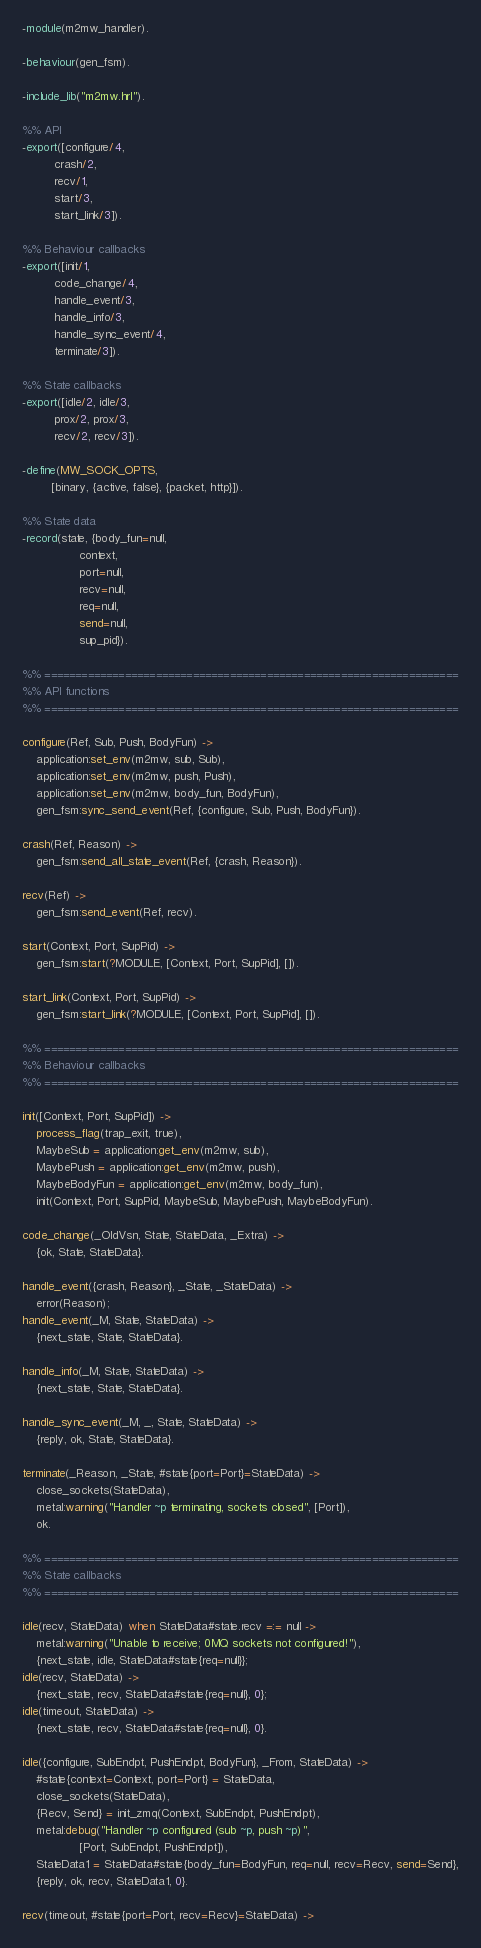Convert code to text. <code><loc_0><loc_0><loc_500><loc_500><_Erlang_>-module(m2mw_handler).

-behaviour(gen_fsm).

-include_lib("m2mw.hrl").

%% API
-export([configure/4,
         crash/2,
         recv/1,
         start/3,
         start_link/3]).

%% Behaviour callbacks
-export([init/1,
         code_change/4,
         handle_event/3,
         handle_info/3,
         handle_sync_event/4,
         terminate/3]).

%% State callbacks
-export([idle/2, idle/3,
         prox/2, prox/3,
         recv/2, recv/3]).

-define(MW_SOCK_OPTS,
        [binary, {active, false}, {packet, http}]).

%% State data
-record(state, {body_fun=null,
                context,
                port=null,
                recv=null,
                req=null,
                send=null,
                sup_pid}).

%% ===================================================================
%% API functions
%% ===================================================================

configure(Ref, Sub, Push, BodyFun) ->
    application:set_env(m2mw, sub, Sub),
    application:set_env(m2mw, push, Push),
    application:set_env(m2mw, body_fun, BodyFun),
    gen_fsm:sync_send_event(Ref, {configure, Sub, Push, BodyFun}).

crash(Ref, Reason) ->
    gen_fsm:send_all_state_event(Ref, {crash, Reason}).

recv(Ref) ->
    gen_fsm:send_event(Ref, recv).

start(Context, Port, SupPid) ->
    gen_fsm:start(?MODULE, [Context, Port, SupPid], []).

start_link(Context, Port, SupPid) ->
    gen_fsm:start_link(?MODULE, [Context, Port, SupPid], []).

%% ===================================================================
%% Behaviour callbacks
%% ===================================================================

init([Context, Port, SupPid]) ->
    process_flag(trap_exit, true),
    MaybeSub = application:get_env(m2mw, sub),
    MaybePush = application:get_env(m2mw, push),
    MaybeBodyFun = application:get_env(m2mw, body_fun),
    init(Context, Port, SupPid, MaybeSub, MaybePush, MaybeBodyFun).

code_change(_OldVsn, State, StateData, _Extra) ->
    {ok, State, StateData}.

handle_event({crash, Reason}, _State, _StateData) ->
    error(Reason);
handle_event(_M, State, StateData) ->
    {next_state, State, StateData}.

handle_info(_M, State, StateData) ->
    {next_state, State, StateData}.

handle_sync_event(_M, _, State, StateData) ->
    {reply, ok, State, StateData}.

terminate(_Reason, _State, #state{port=Port}=StateData) ->
    close_sockets(StateData),
    metal:warning("Handler ~p terminating, sockets closed", [Port]),
    ok.

%% ===================================================================
%% State callbacks
%% ===================================================================
    
idle(recv, StateData) when StateData#state.recv =:= null ->
    metal:warning("Unable to receive; 0MQ sockets not configured!"),
    {next_state, idle, StateData#state{req=null}};
idle(recv, StateData) ->
    {next_state, recv, StateData#state{req=null}, 0};
idle(timeout, StateData) ->
    {next_state, recv, StateData#state{req=null}, 0}.

idle({configure, SubEndpt, PushEndpt, BodyFun}, _From, StateData) ->
    #state{context=Context, port=Port} = StateData,
    close_sockets(StateData),
    {Recv, Send} = init_zmq(Context, SubEndpt, PushEndpt),
    metal:debug("Handler ~p configured (sub ~p, push ~p)",
                [Port, SubEndpt, PushEndpt]),
    StateData1 = StateData#state{body_fun=BodyFun, req=null, recv=Recv, send=Send},
    {reply, ok, recv, StateData1, 0}.

recv(timeout, #state{port=Port, recv=Recv}=StateData) -></code> 